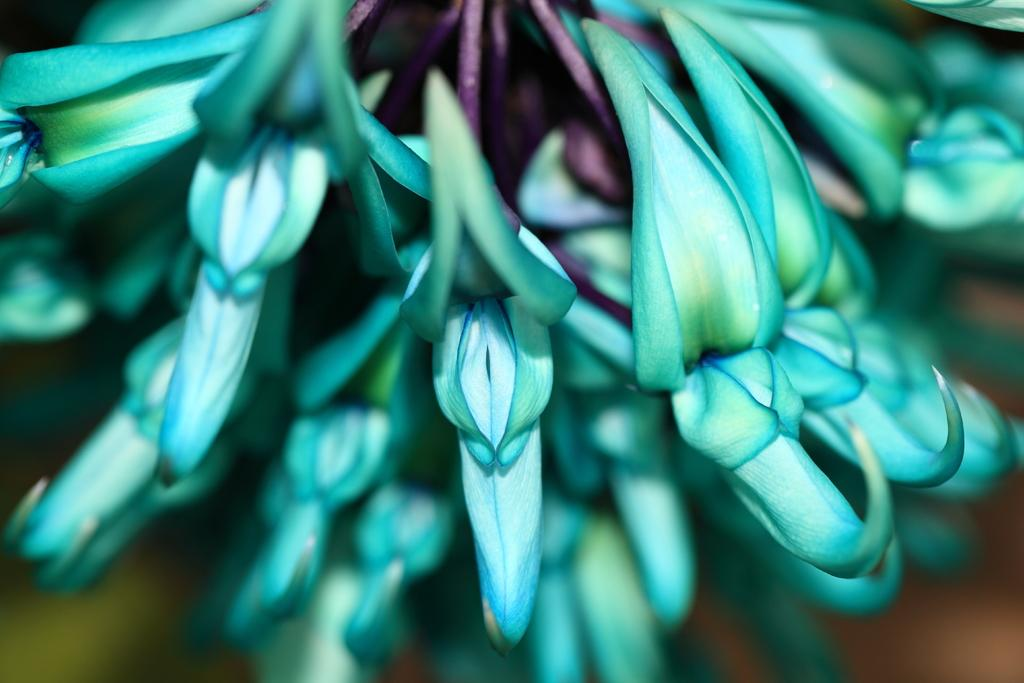What is located in the foreground of the image? There are flowers in the foreground of the image. Can you describe the background of the image? The background of the image is blurry. What page of the book is the faucet located on in the image? There is no book or faucet present in the image; it features flowers in the foreground and a blurry background. 